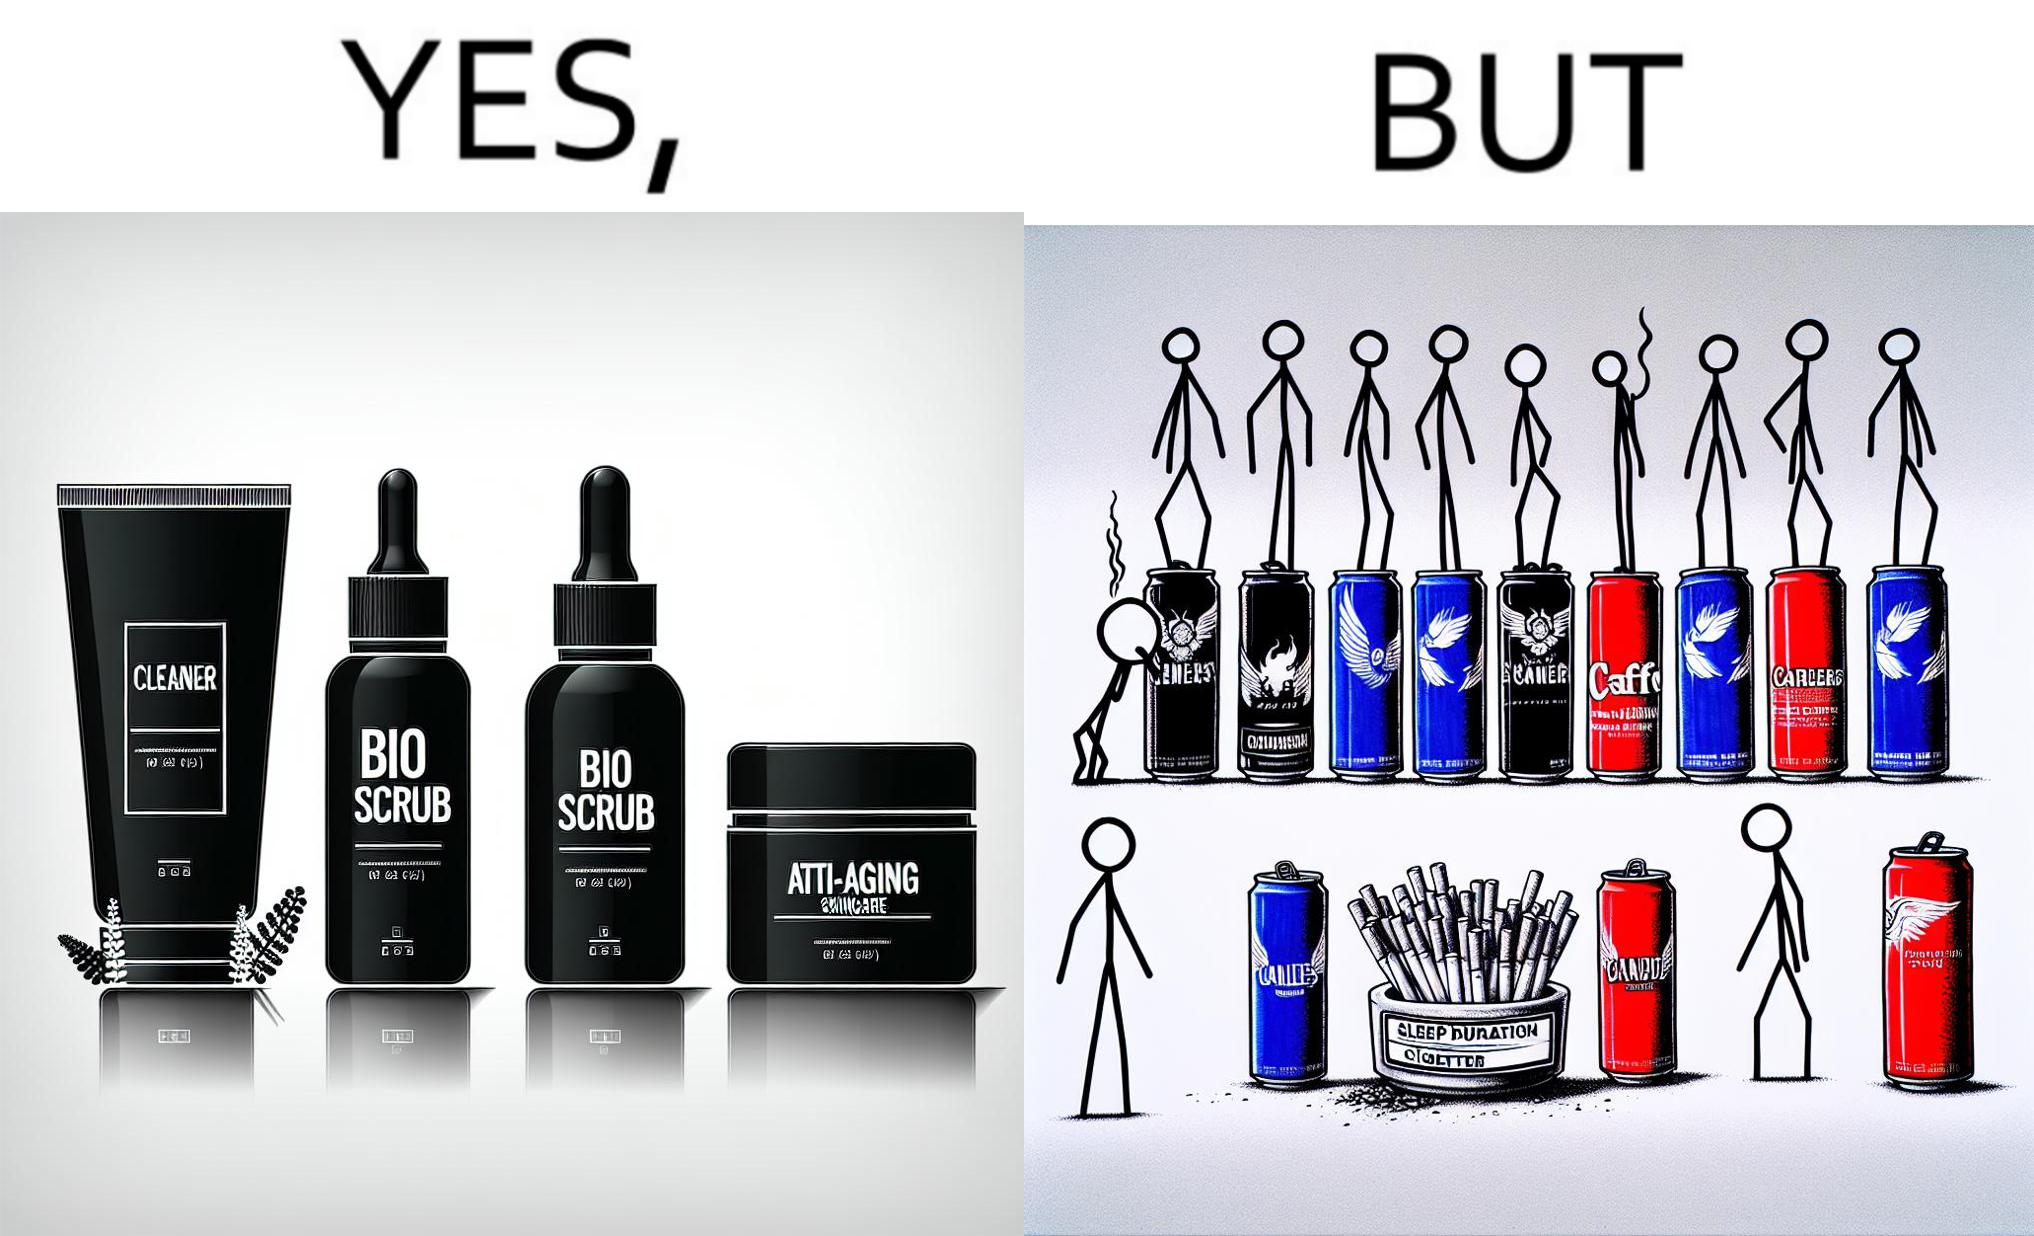Why is this image considered satirical? This image is ironic as on the one hand, the presumed person is into skincare and wants to do the best for their skin, which is good, but on the other hand, they are involved in unhealthy habits that will damage their skin like smoking, caffeine and inadequate sleep. 